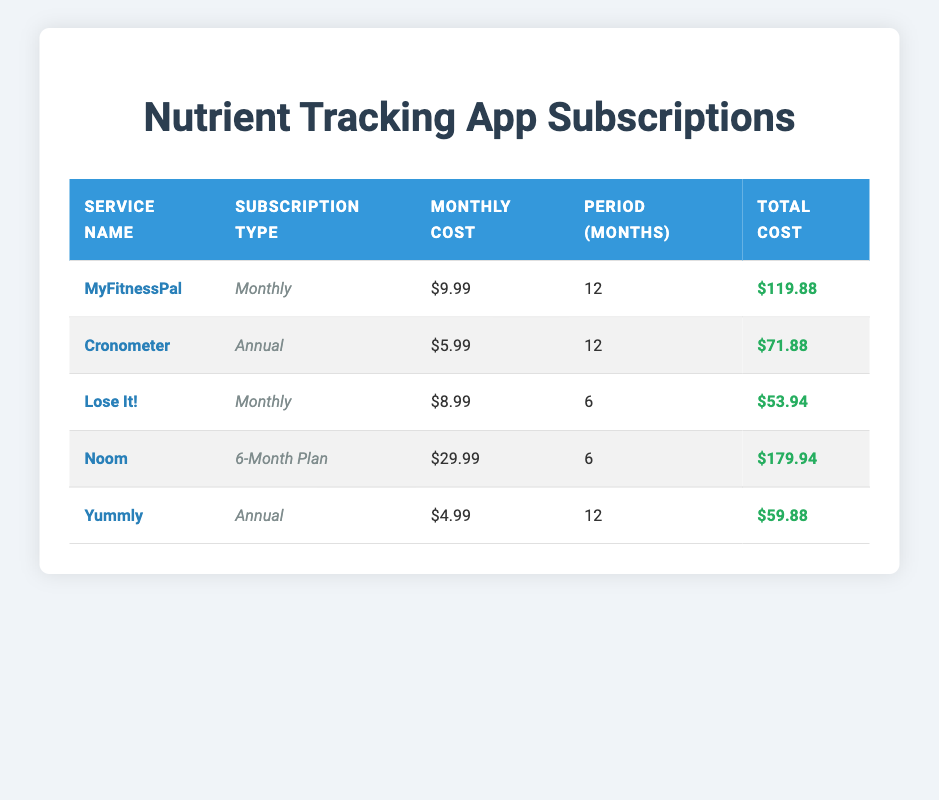What is the monthly cost of MyFitnessPal? The table lists MyFitnessPal under the 'Service Name' column, and the corresponding 'Monthly Cost' column shows $9.99.
Answer: $9.99 How many months is the subscription for Cronometer? The table indicates that Cronometer has a subscription period listed in the 'Period (Months)' column as 12 months.
Answer: 12 What is the total cost for the Lose It! subscription? Looking at the table, the 'Total Cost' for Lose It! is located in the corresponding row and shows $53.94.
Answer: $53.94 Is Yummly's subscription cheaper or more expensive than MyFitnessPal's? The table shows Yummly as having a total cost of $59.88 and MyFitnessPal having $119.88. Therefore, Yummly is cheaper, as $59.88 is less than $119.88.
Answer: Cheaper What is the difference in monthly cost between Noom and Cronometer? The monthly cost for Noom is $29.99, and for Cronometer, it is $5.99. The difference is calculated as $29.99 - $5.99 = $24.00.
Answer: $24.00 Which service has the highest total cost, and what is that amount? By comparing the 'Total Cost' values, Noom has the highest total cost at $179.94, as other values are lower.
Answer: Noom; $179.94 What is the average monthly cost of all the services? To find the average, sum all monthly costs ($9.99 + $5.99 + $8.99 + $29.99 + $4.99 = $59.95) and divide by the number of services (5). The average is $59.95 / 5 = $11.99.
Answer: $11.99 How many subscription services are offered on a monthly basis? By reviewing the table, MyFitnessPal and Lose It! are marked as 'Monthly' in the 'Subscription Type' column, making the count 2.
Answer: 2 Does the Cronometer subscription cost less than $80 in total? The total cost for Cronometer is $71.88, which is less than $80, thus confirming that it is true.
Answer: Yes What service has the lowest monthly cost, and what is the amount? Looking at the table, Yummly has the lowest monthly cost of $4.99, handily seen in the 'Monthly Cost' column.
Answer: Yummly; $4.99 